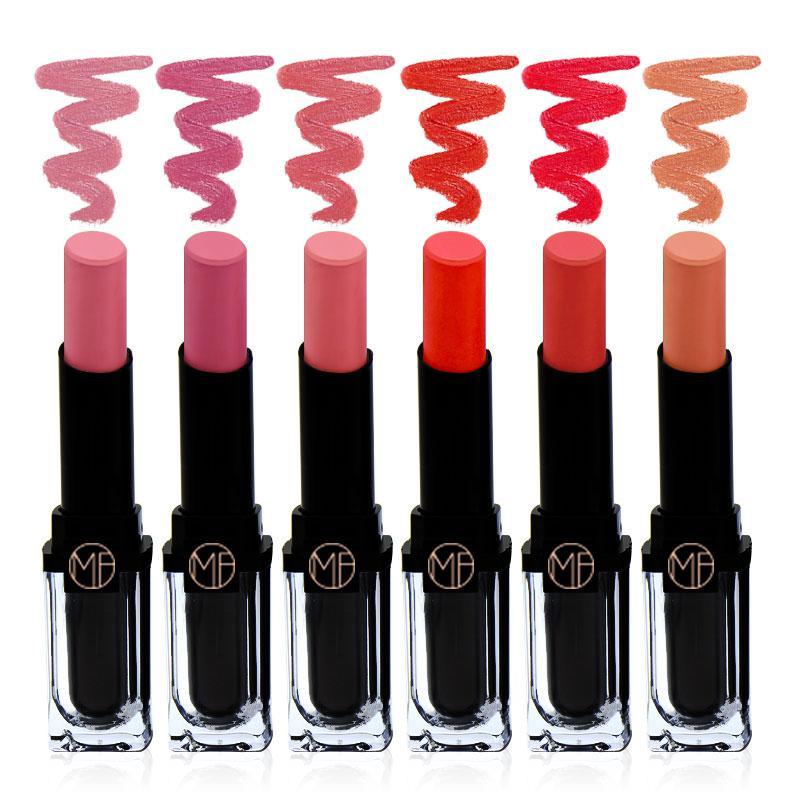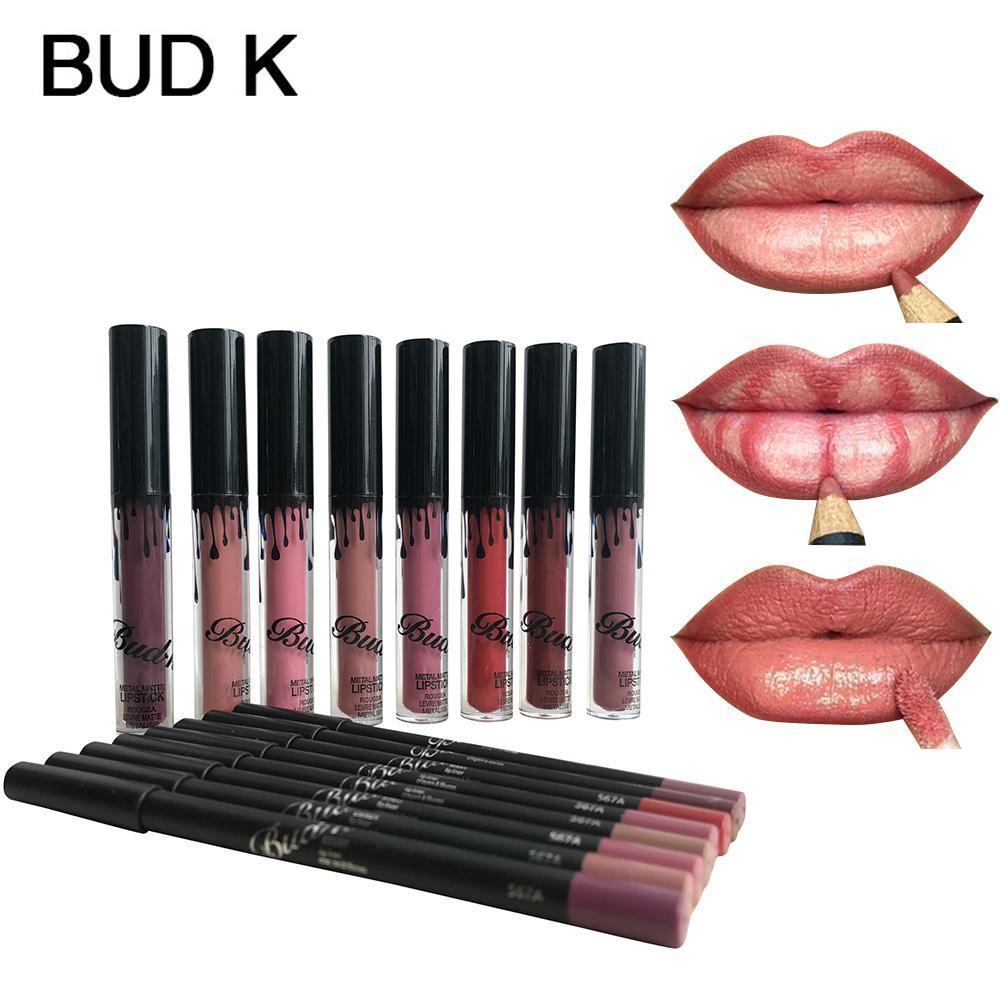The first image is the image on the left, the second image is the image on the right. Evaluate the accuracy of this statement regarding the images: "At least one of the images shows exactly three mouths.". Is it true? Answer yes or no. Yes. 